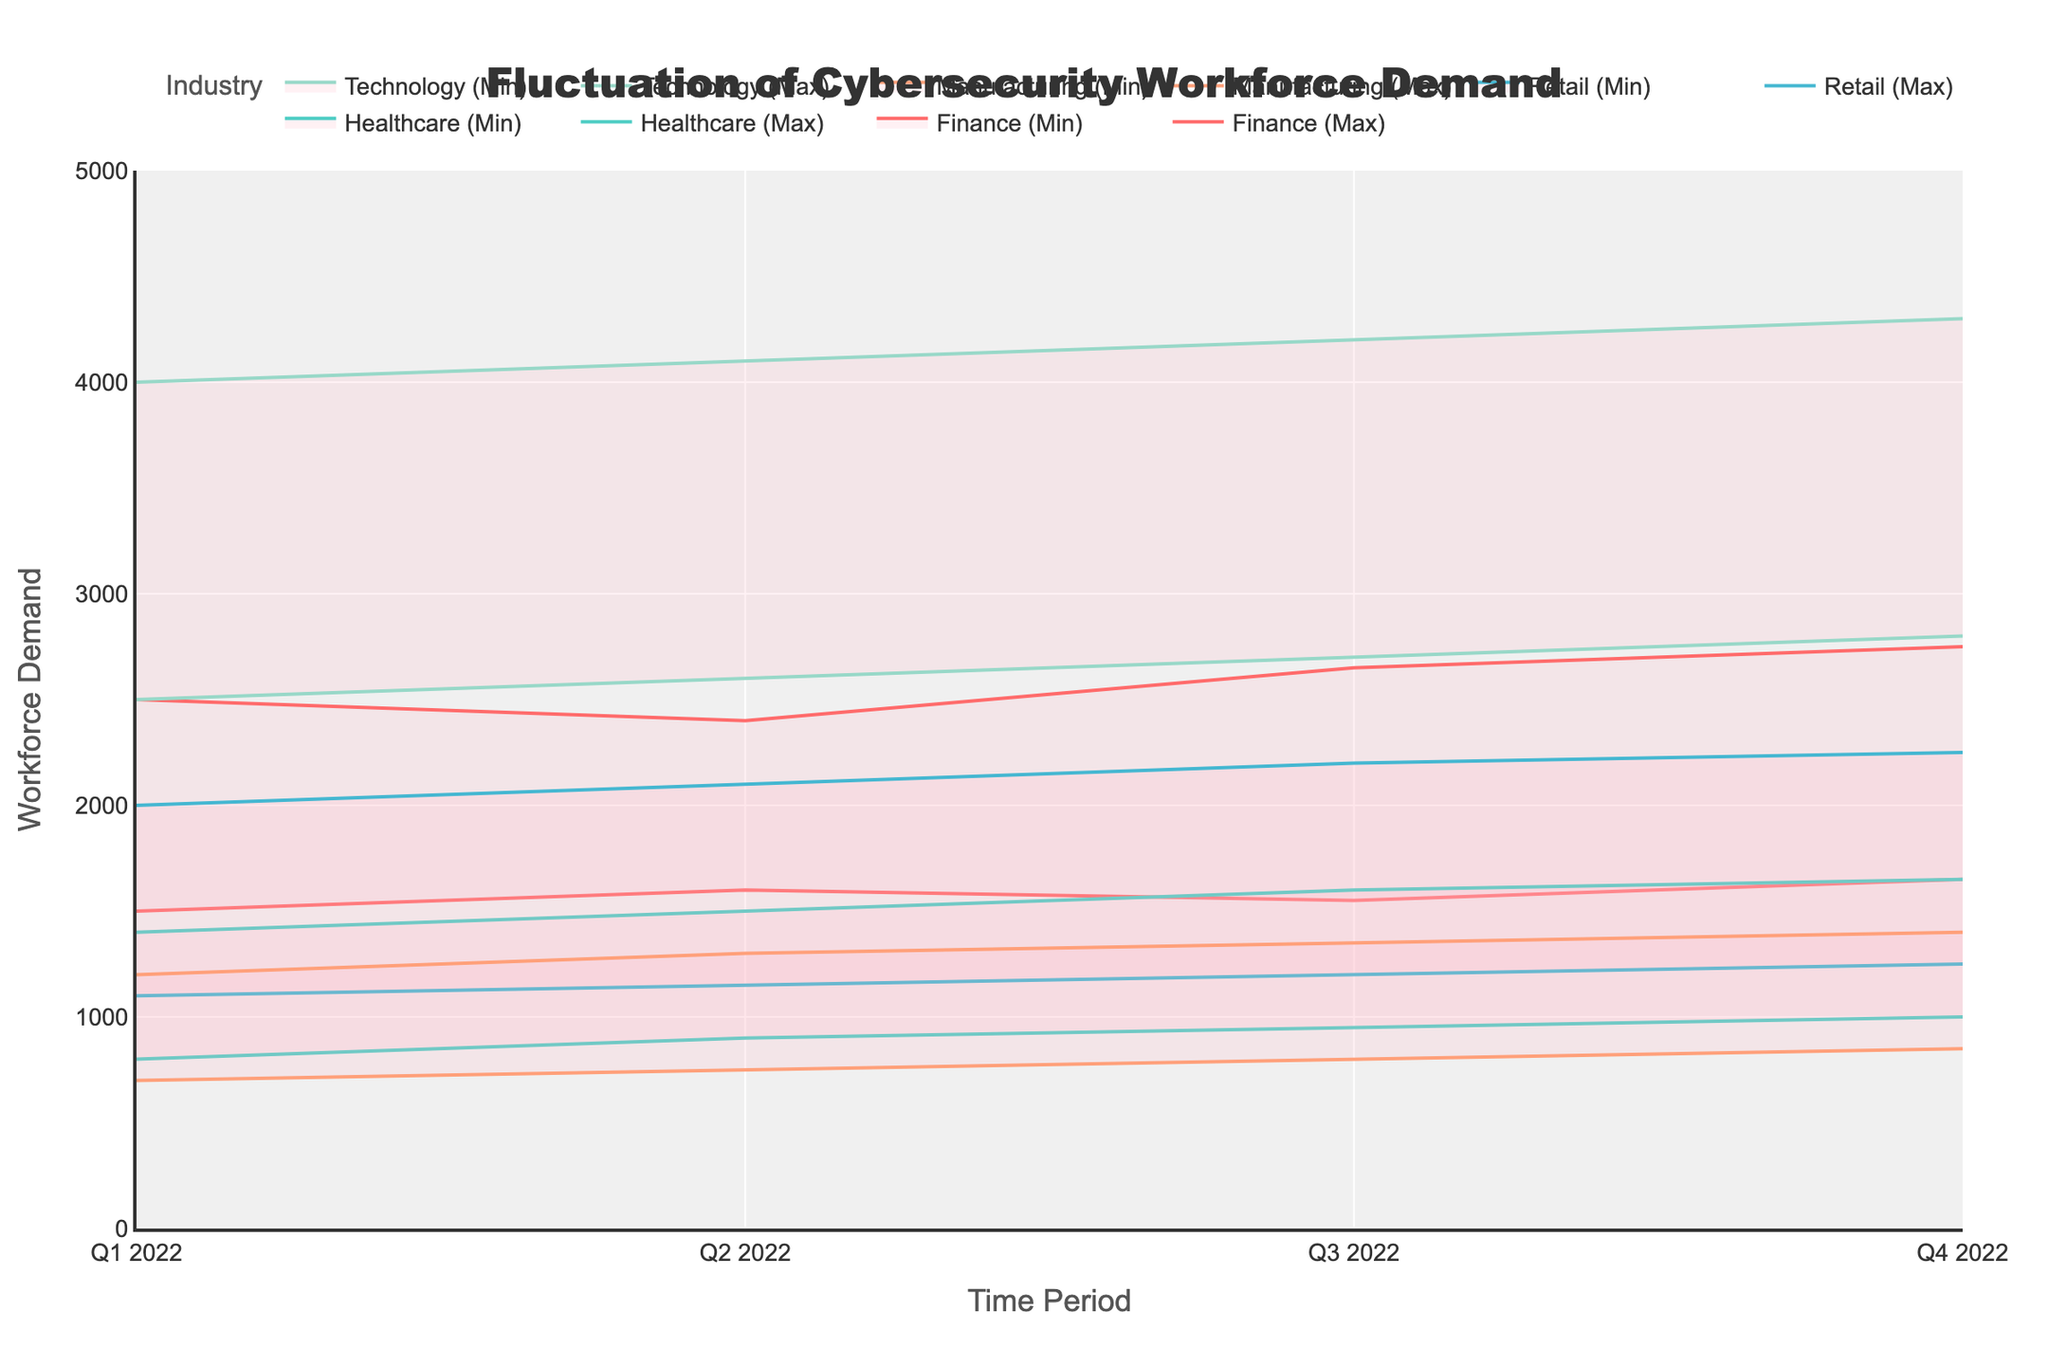What is the title of the chart? The title is usually positioned at the top center of the chart, displaying the main subject. Here, it states "Fluctuation of Cybersecurity Workforce Demand"
Answer: Fluctuation of Cybersecurity Workforce Demand How many time periods are displayed on the x-axis? Look at the x-axis at the bottom of the chart. Count the number of distinct time periods shown from Q1 2022 to Q4 2022. There should be four periods.
Answer: Four Which industry in North America had the highest maximum workforce demand in Q4 2022? Identify the line indicating maximum demand for industries in North America. Compare the maximum values for Finance and Technology during Q4 2022, Technology had the highest demand.
Answer: Technology What is the approximate range of workforce demand for the Healthcare industry in Q3 2022? Find the Healthcare industry data and locate Q3 2022. Note the minimum and maximum values, they range from about 950 to 1600.
Answer: 950 to 1600 How does the workforce demand in the Retail industry change from Q1 2022 to Q2 2022 in Asia Pacific? Track the Retail industry lines for Asia Pacific from Q1 to Q2 2022. Observe the increase in both minimum and maximum values from 1100-2000 to 1150-2100.
Answer: Increase Which industry showed the most consistent workforce demand in South America across all time periods? Identify the industry in South America (Manufacturing) and check its min and max demand across Q1 to Q4 2022. It consistently slopes upward with less fluctuation in difference.
Answer: Manufacturing What was the difference in the maximum workforce demand between Technology and Finance in North America during Q4 2022? Subtract the maximum demand for Finance from that of Technology during Q4 2022. Technology had 4300, and Finance had 2750. Therefore, the difference is 4300 - 2750 = 1550.
Answer: 1550 Which region showed the highest volatility in workforce demand for any given industry? Volatility refers to how much the workforce demand changes over time. Technology in North America shows large fluctuations from 2500–4000 in Q1 2022 to 2800-4300 in Q4 2022.
Answer: North America (Technology) What was the minimum workforce demand for the Manufacturing industry in South America in Q2 2022? Find the data for Manufacturing in South America for Q2 2022. The minimum value for this period is indicated on the chart.
Answer: 750 During which quarter did the Healthcare industry in Europe have its highest maximum demand? Track the Healthcare industry line for Europe and find where the peak maximum demand is. It is in Q4 2022 with a demand of 1650.
Answer: Q4 2022 